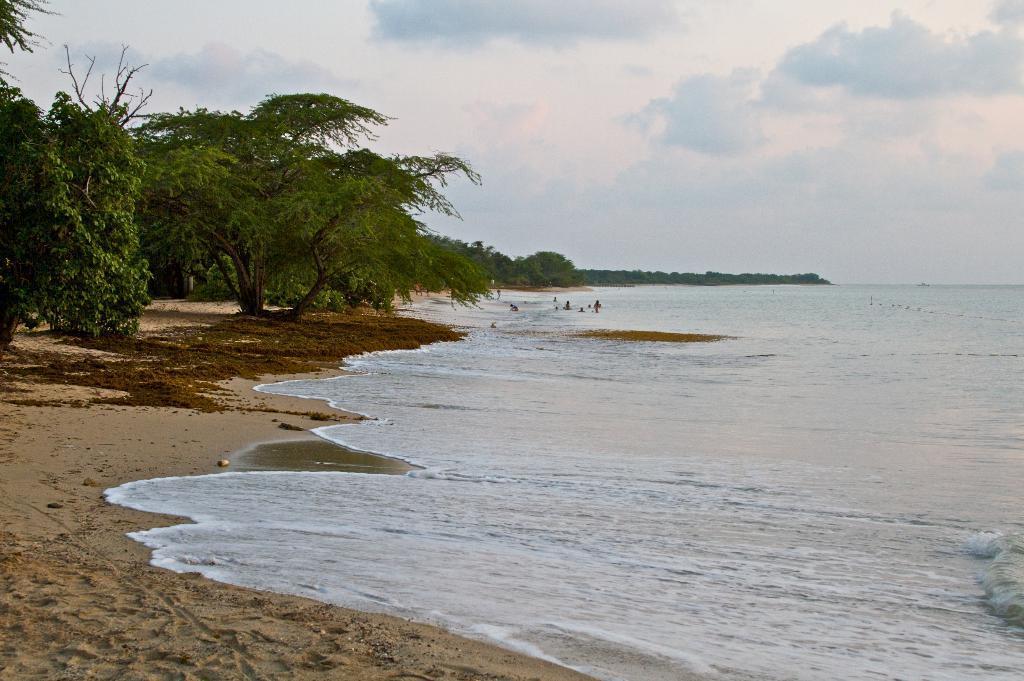Describe this image in one or two sentences. In this image on the right side, I can see the water. On the left side I can see the trees. At the top I can see the clouds in the sky. 